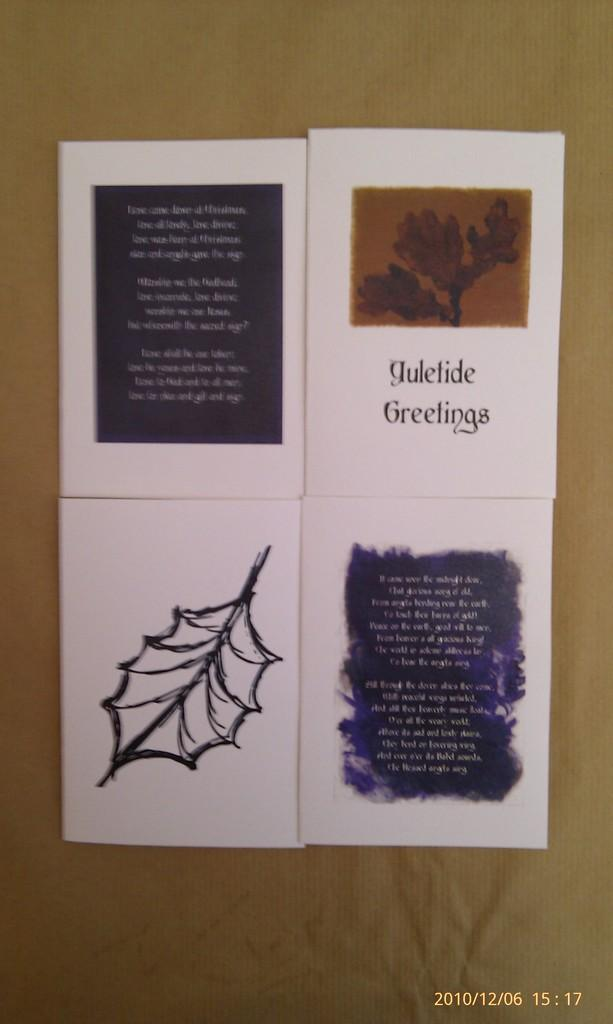<image>
Present a compact description of the photo's key features. A photograph of Yuletide Greetings cards was taken on 12/06/2010. 